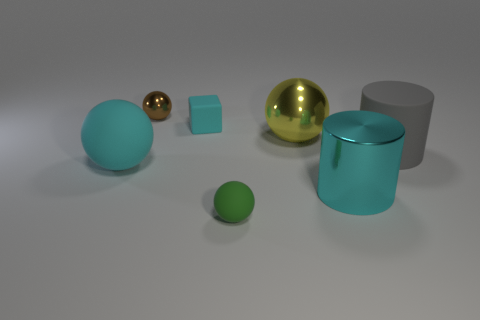How many things are either big things that are behind the gray matte thing or cylinders that are right of the big yellow ball?
Make the answer very short. 3. Do the gray object and the green thing have the same size?
Give a very brief answer. No. Is there anything else that has the same size as the brown metallic sphere?
Provide a succinct answer. Yes. Is the shape of the object that is on the right side of the large cyan cylinder the same as the large thing on the left side of the small block?
Your answer should be compact. No. The green rubber thing is what size?
Offer a very short reply. Small. There is a tiny thing that is in front of the metal thing in front of the cyan matte object in front of the small cyan matte block; what is its material?
Give a very brief answer. Rubber. What number of other things are the same color as the big shiny cylinder?
Offer a very short reply. 2. How many purple objects are cubes or metallic things?
Your answer should be compact. 0. There is a cylinder that is in front of the cyan sphere; what is it made of?
Your answer should be very brief. Metal. Do the tiny thing that is behind the small cyan rubber block and the green object have the same material?
Your answer should be very brief. No. 